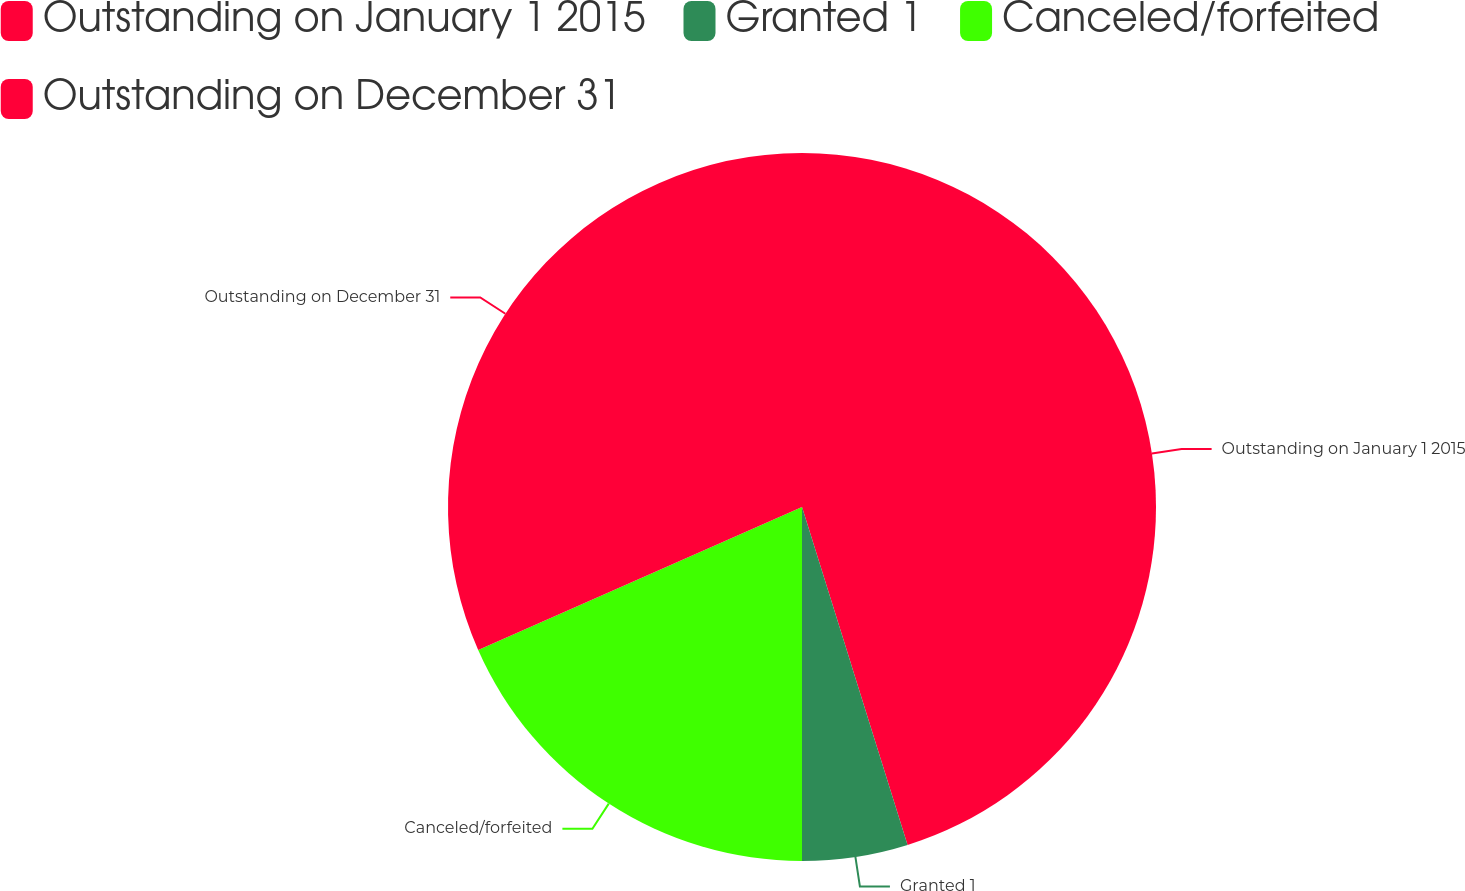Convert chart. <chart><loc_0><loc_0><loc_500><loc_500><pie_chart><fcel>Outstanding on January 1 2015<fcel>Granted 1<fcel>Canceled/forfeited<fcel>Outstanding on December 31<nl><fcel>45.18%<fcel>4.82%<fcel>18.38%<fcel>31.62%<nl></chart> 